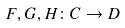Convert formula to latex. <formula><loc_0><loc_0><loc_500><loc_500>F , G , H \colon C \to D</formula> 